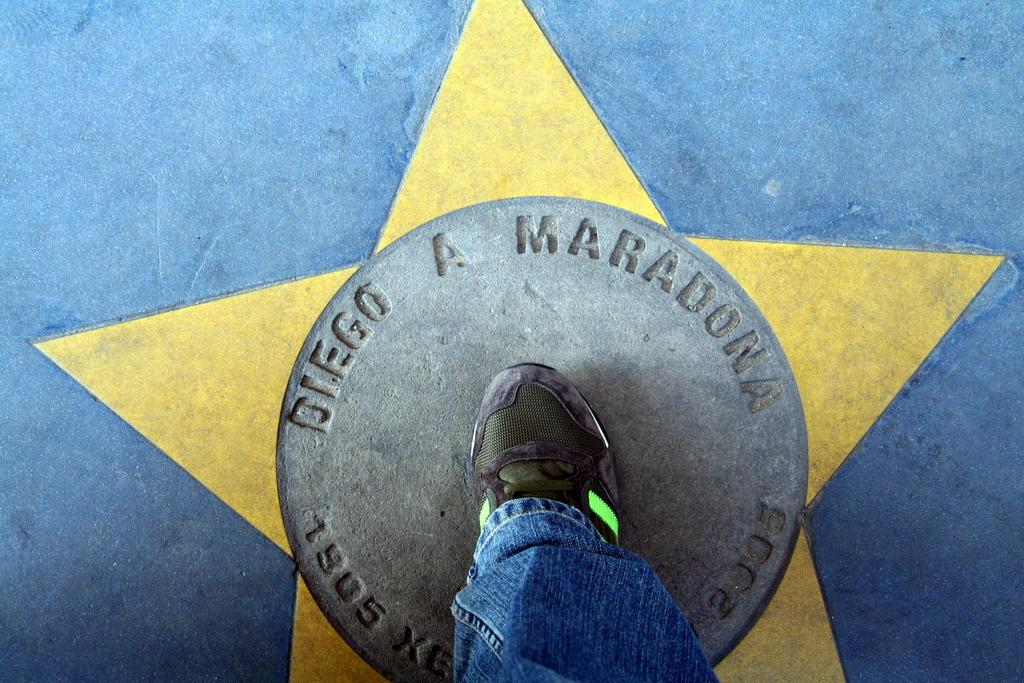What body part is visible in the image? There is a human leg in the image. Where is the human leg located in the image? The human leg is at the bottom of the image. What type of surface is visible in the background of the image? There is a floor in the background of the image. How many rabbits can be seen playing with the human leg in the image? There are no rabbits present in the image, and the human leg is not interacting with any animals. 